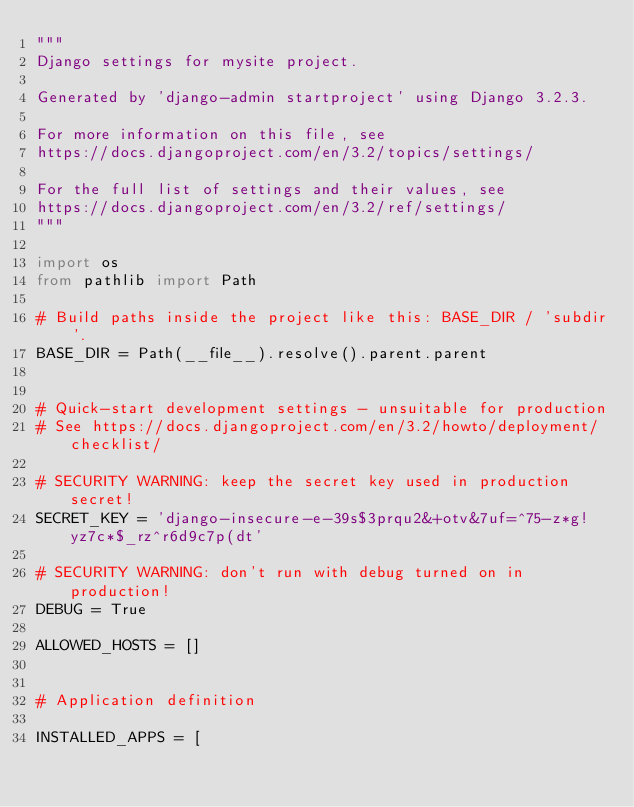Convert code to text. <code><loc_0><loc_0><loc_500><loc_500><_Python_>"""
Django settings for mysite project.

Generated by 'django-admin startproject' using Django 3.2.3.

For more information on this file, see
https://docs.djangoproject.com/en/3.2/topics/settings/

For the full list of settings and their values, see
https://docs.djangoproject.com/en/3.2/ref/settings/
"""

import os
from pathlib import Path

# Build paths inside the project like this: BASE_DIR / 'subdir'.
BASE_DIR = Path(__file__).resolve().parent.parent


# Quick-start development settings - unsuitable for production
# See https://docs.djangoproject.com/en/3.2/howto/deployment/checklist/

# SECURITY WARNING: keep the secret key used in production secret!
SECRET_KEY = 'django-insecure-e-39s$3prqu2&+otv&7uf=^75-z*g!yz7c*$_rz^r6d9c7p(dt'

# SECURITY WARNING: don't run with debug turned on in production!
DEBUG = True

ALLOWED_HOSTS = []


# Application definition

INSTALLED_APPS = [</code> 